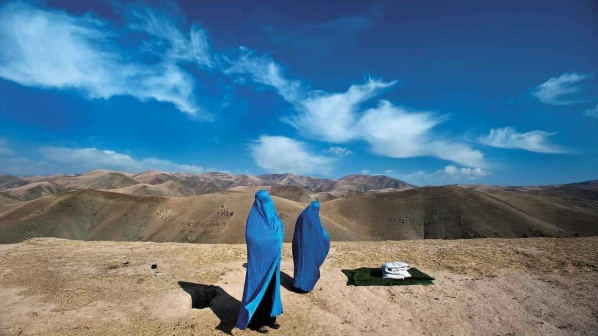Describe a possible short scenario involving these women. The two women took a brief break from their journey, using the spread cloth for a quick lunch. As they sat, they marveled at the vast landscape, sharing a quiet moment of appreciation. Noor, their faithful dog, lay close by, ensuring they were safe. After their rest, they gathered their belongings and continued their trek, feeling rejuvenated and inspired by the beauty around them. 